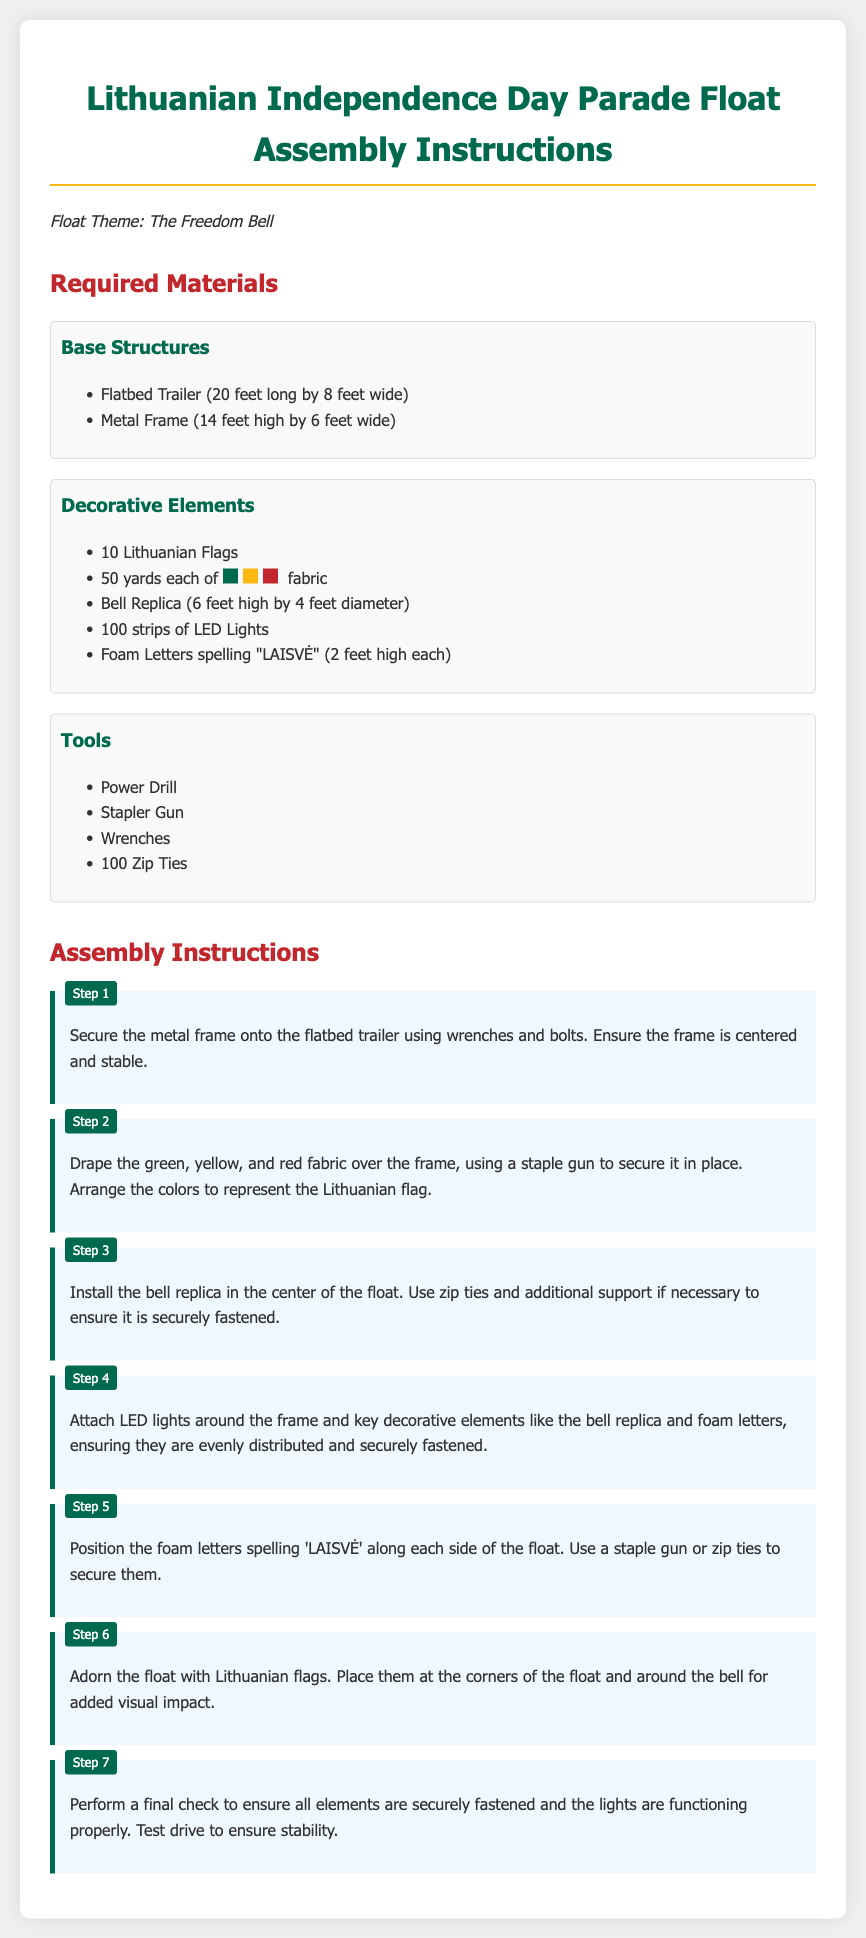What is the float theme? The float theme is stated at the beginning of the document as "The Freedom Bell."
Answer: The Freedom Bell How many Lithuanian flags are required? The document specifically mentions needing a total of 10 Lithuanian flags for the float.
Answer: 10 What is the height of the bell replica? The bell replica's height is provided in the materials section, listed as 6 feet high.
Answer: 6 feet What colors of fabric are used to represent the Lithuanian flag? The document lists the colors used as green, yellow, and red fabric.
Answer: Green, yellow, and red How many steps are in the assembly instructions? The assembly instructions contain seven steps that guide the assembly process.
Answer: 7 What should be checked in the final step? The final step instructs to check that all elements are securely fastened and the lights are functioning properly.
Answer: All elements and lights What tool is used to secure the foam letters? According to the instructions, a staple gun or zip ties is used to secure the foam letters spelling "LAISVĖ."
Answer: Staple gun or zip ties 